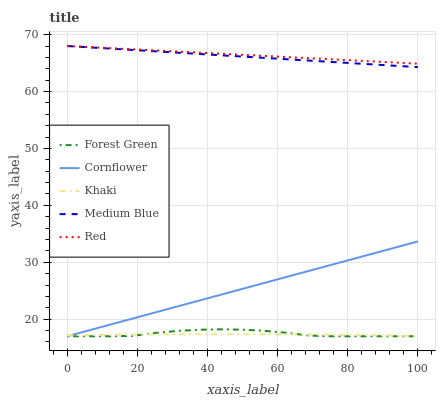Does Khaki have the minimum area under the curve?
Answer yes or no. Yes. Does Red have the maximum area under the curve?
Answer yes or no. Yes. Does Forest Green have the minimum area under the curve?
Answer yes or no. No. Does Forest Green have the maximum area under the curve?
Answer yes or no. No. Is Medium Blue the smoothest?
Answer yes or no. Yes. Is Forest Green the roughest?
Answer yes or no. Yes. Is Khaki the smoothest?
Answer yes or no. No. Is Khaki the roughest?
Answer yes or no. No. Does Khaki have the lowest value?
Answer yes or no. No. Does Red have the highest value?
Answer yes or no. Yes. Does Forest Green have the highest value?
Answer yes or no. No. Is Forest Green less than Red?
Answer yes or no. Yes. Is Red greater than Khaki?
Answer yes or no. Yes. Does Red intersect Medium Blue?
Answer yes or no. Yes. Is Red less than Medium Blue?
Answer yes or no. No. Is Red greater than Medium Blue?
Answer yes or no. No. Does Forest Green intersect Red?
Answer yes or no. No. 